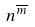Convert formula to latex. <formula><loc_0><loc_0><loc_500><loc_500>n ^ { \overline { m } }</formula> 